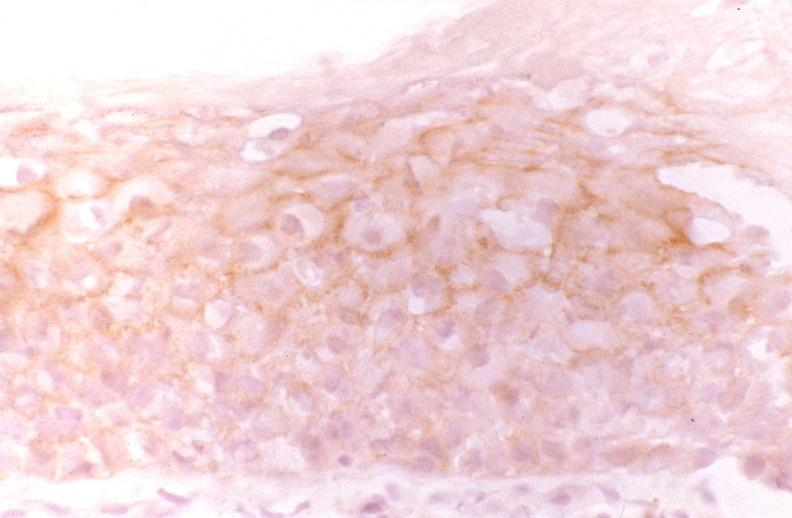what does this image show?
Answer the question using a single word or phrase. Oral dysplasia 